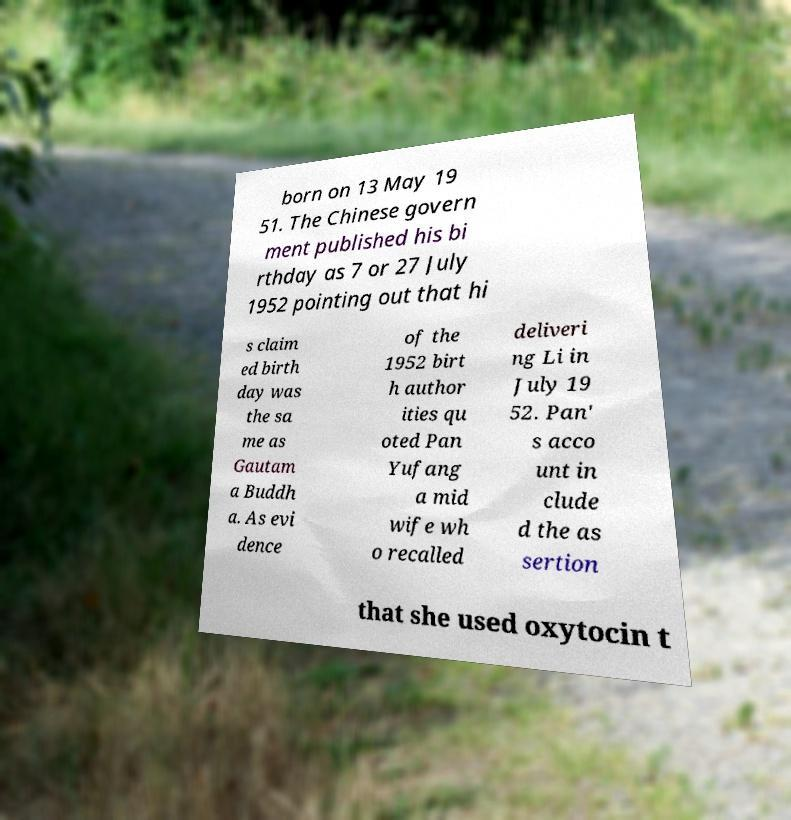For documentation purposes, I need the text within this image transcribed. Could you provide that? born on 13 May 19 51. The Chinese govern ment published his bi rthday as 7 or 27 July 1952 pointing out that hi s claim ed birth day was the sa me as Gautam a Buddh a. As evi dence of the 1952 birt h author ities qu oted Pan Yufang a mid wife wh o recalled deliveri ng Li in July 19 52. Pan' s acco unt in clude d the as sertion that she used oxytocin t 